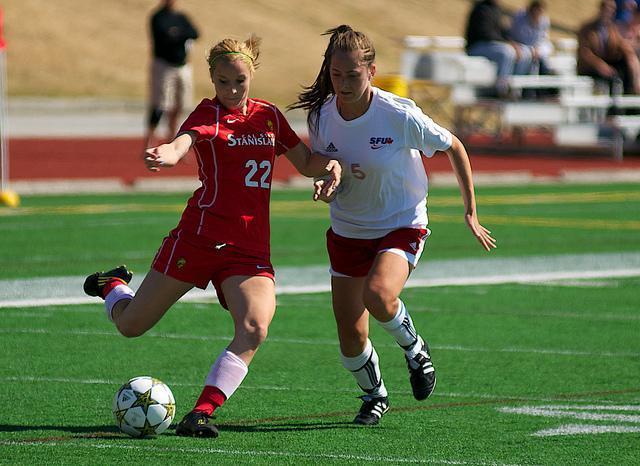How many people are there?
Give a very brief answer. 6. How many teddy bears are wearing a hair bow?
Give a very brief answer. 0. 